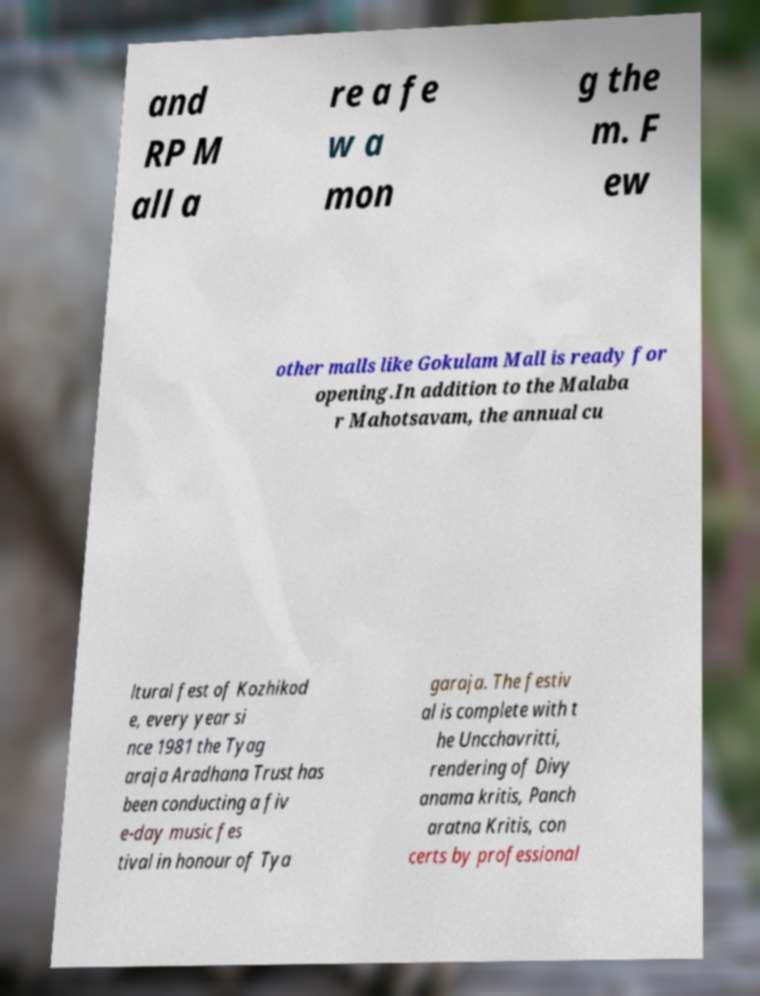Can you accurately transcribe the text from the provided image for me? and RP M all a re a fe w a mon g the m. F ew other malls like Gokulam Mall is ready for opening.In addition to the Malaba r Mahotsavam, the annual cu ltural fest of Kozhikod e, every year si nce 1981 the Tyag araja Aradhana Trust has been conducting a fiv e-day music fes tival in honour of Tya garaja. The festiv al is complete with t he Uncchavritti, rendering of Divy anama kritis, Panch aratna Kritis, con certs by professional 